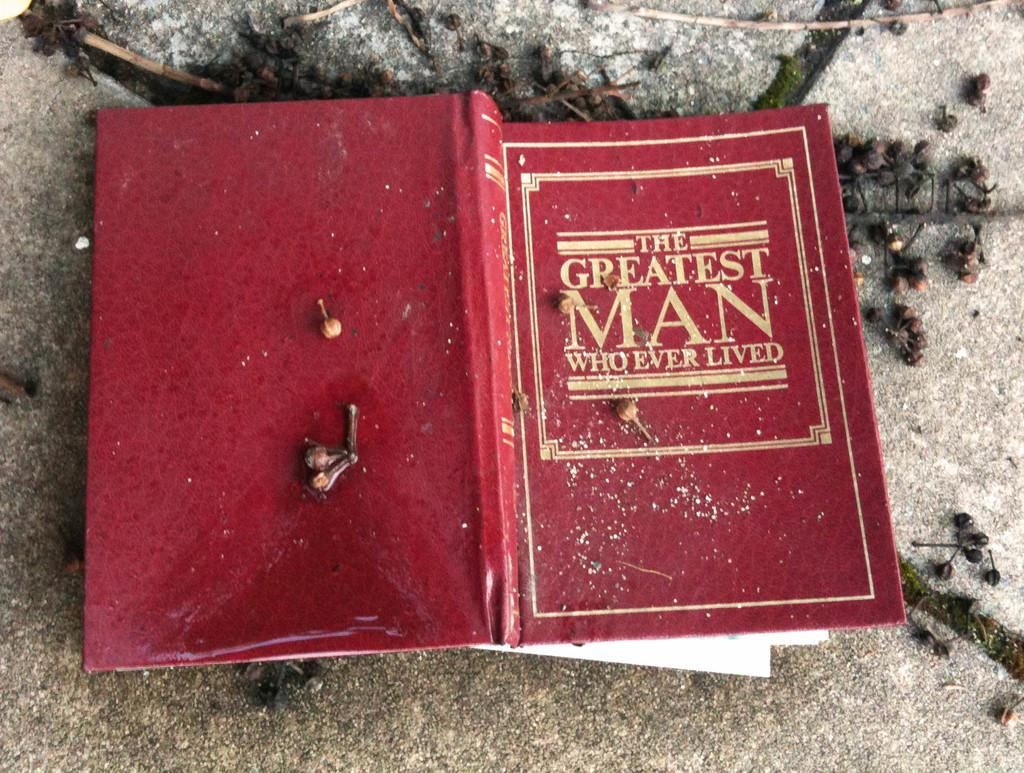<image>
Write a terse but informative summary of the picture. A copy of "The Greatest Man Who Ever Lived" had fallen on the icy ground and looked slightly damaged. 